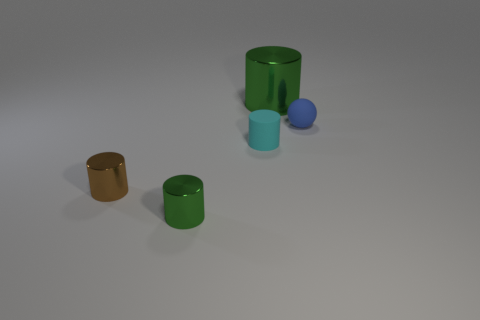How many tiny objects are metal cylinders or metallic cubes? In the image, there are a total of two objects that could be perceived as metal cylinders or metallic cubes based on their shapes and reflective surfaces. 